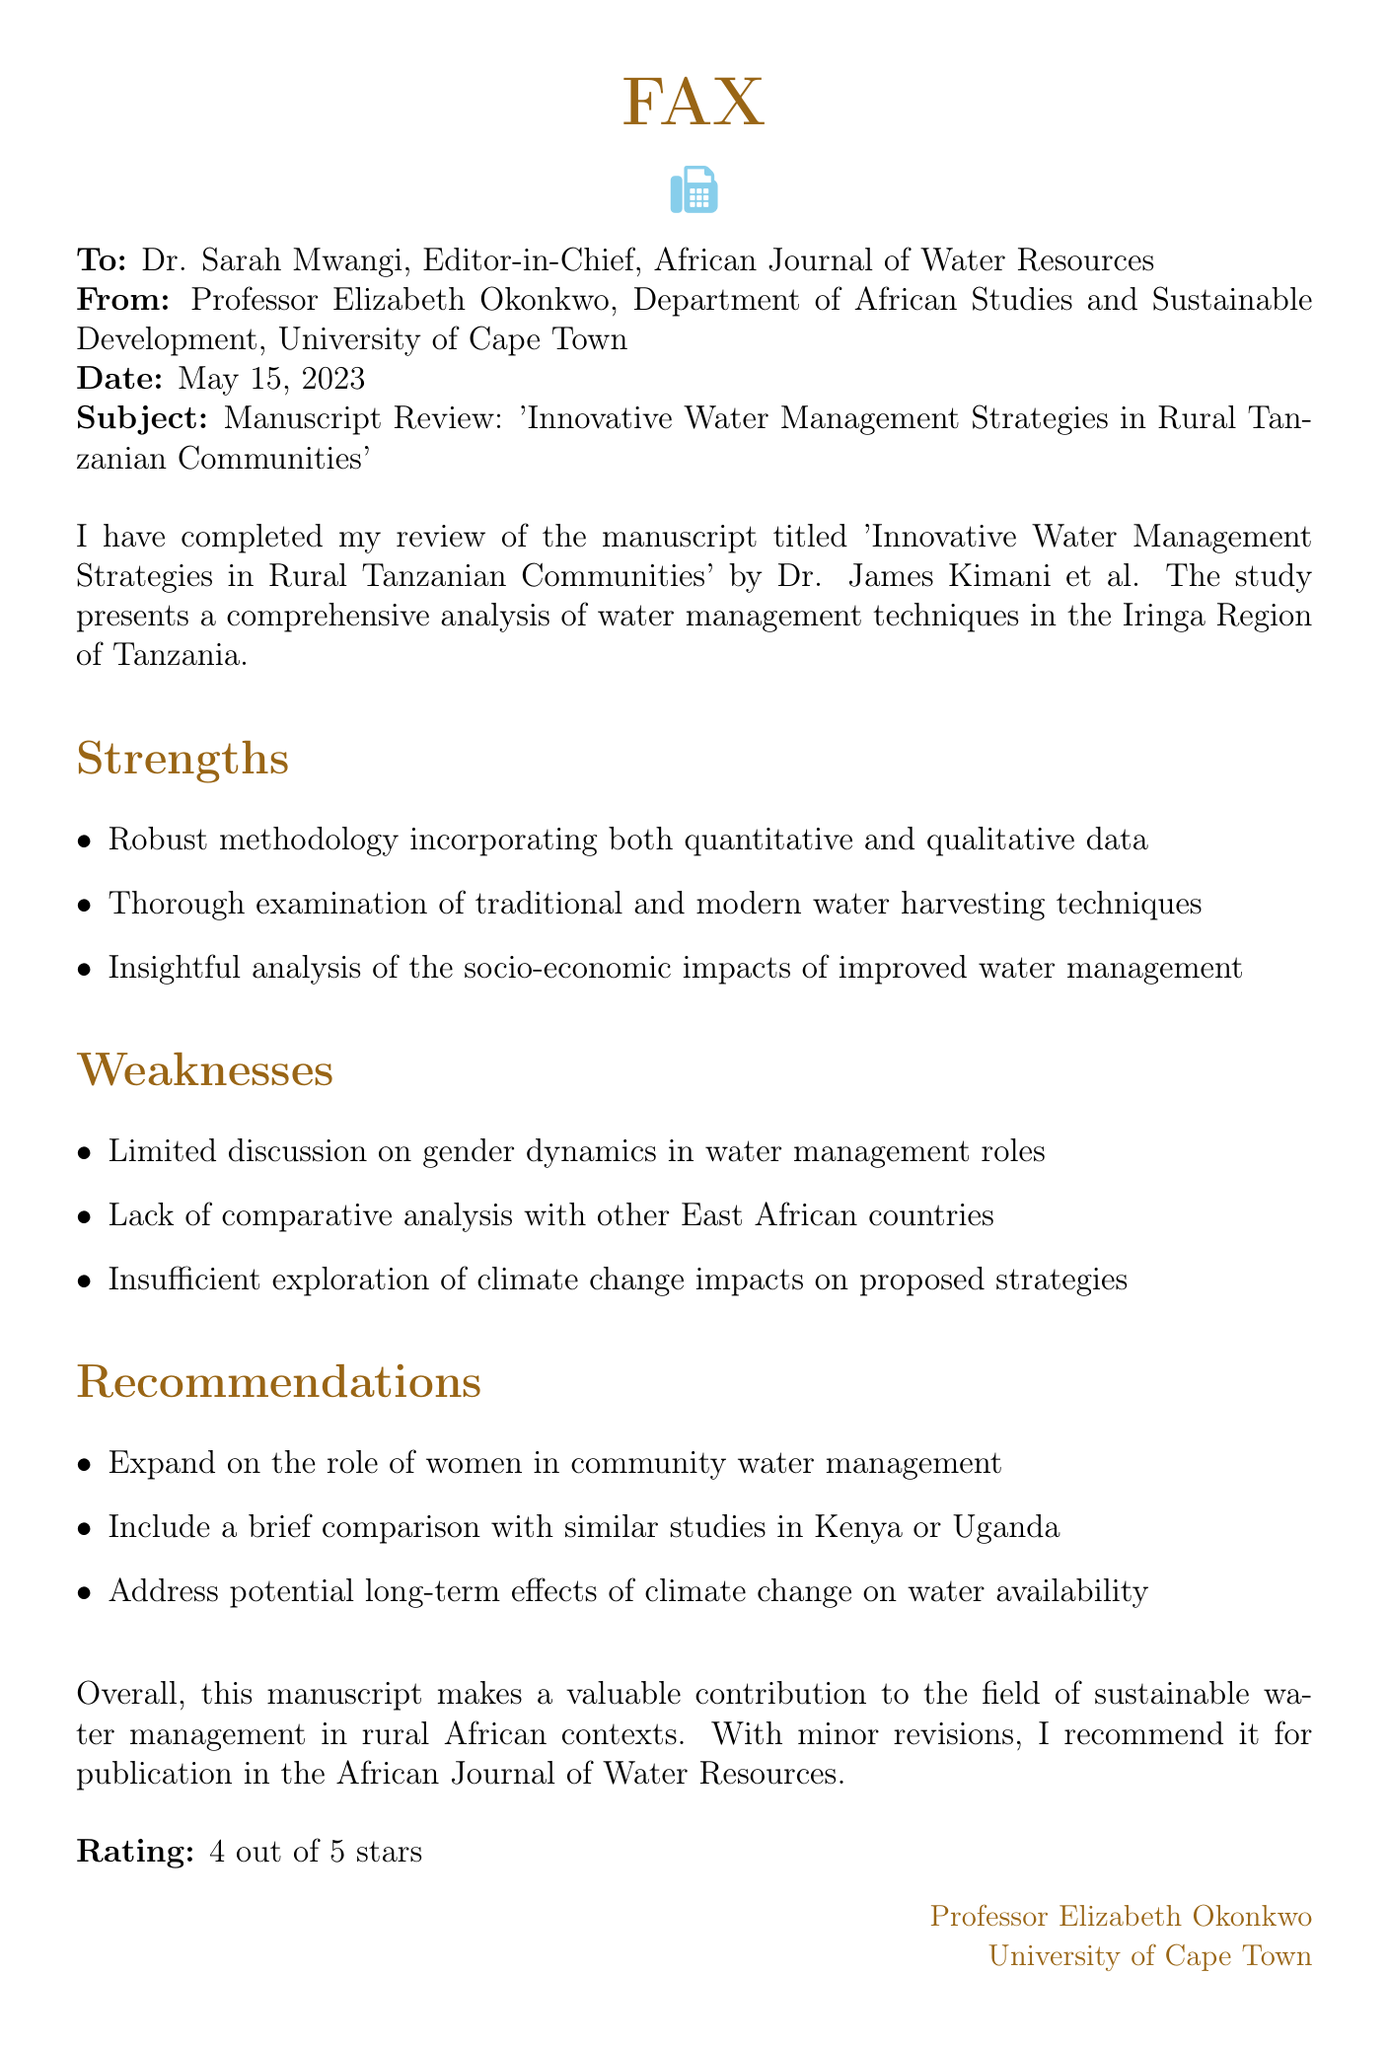What is the title of the manuscript reviewed? The title of the manuscript is mentioned at the start of the fax.
Answer: Innovative Water Management Strategies in Rural Tanzanian Communities Who is the author of the manuscript? The author's name is identified in the first part of the document.
Answer: Dr. James Kimani What is the date of the fax? The date is specified in the header of the fax.
Answer: May 15, 2023 What is the overall rating given to the manuscript? The rating is provided at the end of the review.
Answer: 4 out of 5 stars What are the strengths of the manuscript mentioned? The strengths are listed under a specific section within the document.
Answer: Robust methodology incorporating both quantitative and qualitative data What weakness relates to gender dynamics? One of the weaknesses highlights a specific theme regarding roles in water management.
Answer: Limited discussion on gender dynamics in water management roles What does Dr. Okonkwo recommend including in the revisions? The recommendations are enumerated clearly in a section of the document.
Answer: Expand on the role of women in community water management What is the department of the sender? The sender's department is listed in the header of the fax.
Answer: Department of African Studies and Sustainable Development What is the name of the journal? The journal's name is identified in the header addressed to the editor.
Answer: African Journal of Water Resources 